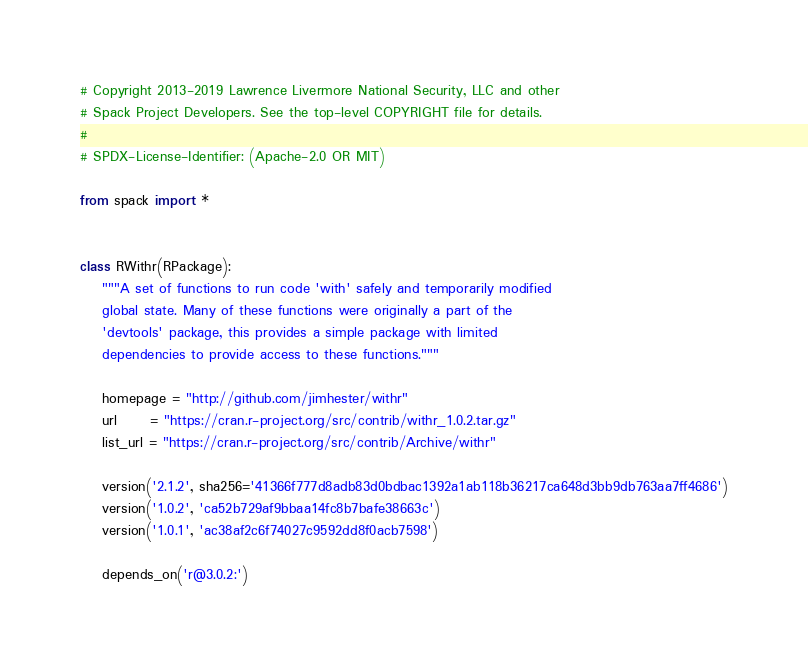Convert code to text. <code><loc_0><loc_0><loc_500><loc_500><_Python_># Copyright 2013-2019 Lawrence Livermore National Security, LLC and other
# Spack Project Developers. See the top-level COPYRIGHT file for details.
#
# SPDX-License-Identifier: (Apache-2.0 OR MIT)

from spack import *


class RWithr(RPackage):
    """A set of functions to run code 'with' safely and temporarily modified
    global state. Many of these functions were originally a part of the
    'devtools' package, this provides a simple package with limited
    dependencies to provide access to these functions."""

    homepage = "http://github.com/jimhester/withr"
    url      = "https://cran.r-project.org/src/contrib/withr_1.0.2.tar.gz"
    list_url = "https://cran.r-project.org/src/contrib/Archive/withr"

    version('2.1.2', sha256='41366f777d8adb83d0bdbac1392a1ab118b36217ca648d3bb9db763aa7ff4686')
    version('1.0.2', 'ca52b729af9bbaa14fc8b7bafe38663c')
    version('1.0.1', 'ac38af2c6f74027c9592dd8f0acb7598')

    depends_on('r@3.0.2:')
</code> 